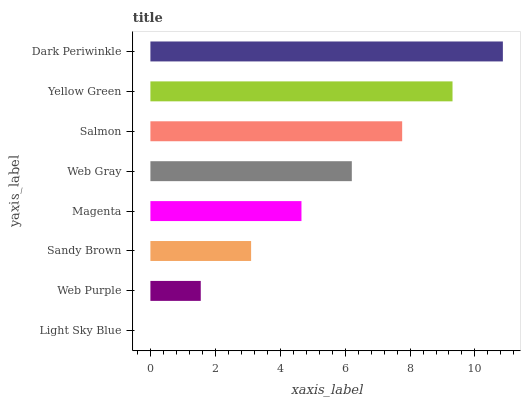Is Light Sky Blue the minimum?
Answer yes or no. Yes. Is Dark Periwinkle the maximum?
Answer yes or no. Yes. Is Web Purple the minimum?
Answer yes or no. No. Is Web Purple the maximum?
Answer yes or no. No. Is Web Purple greater than Light Sky Blue?
Answer yes or no. Yes. Is Light Sky Blue less than Web Purple?
Answer yes or no. Yes. Is Light Sky Blue greater than Web Purple?
Answer yes or no. No. Is Web Purple less than Light Sky Blue?
Answer yes or no. No. Is Web Gray the high median?
Answer yes or no. Yes. Is Magenta the low median?
Answer yes or no. Yes. Is Salmon the high median?
Answer yes or no. No. Is Web Gray the low median?
Answer yes or no. No. 